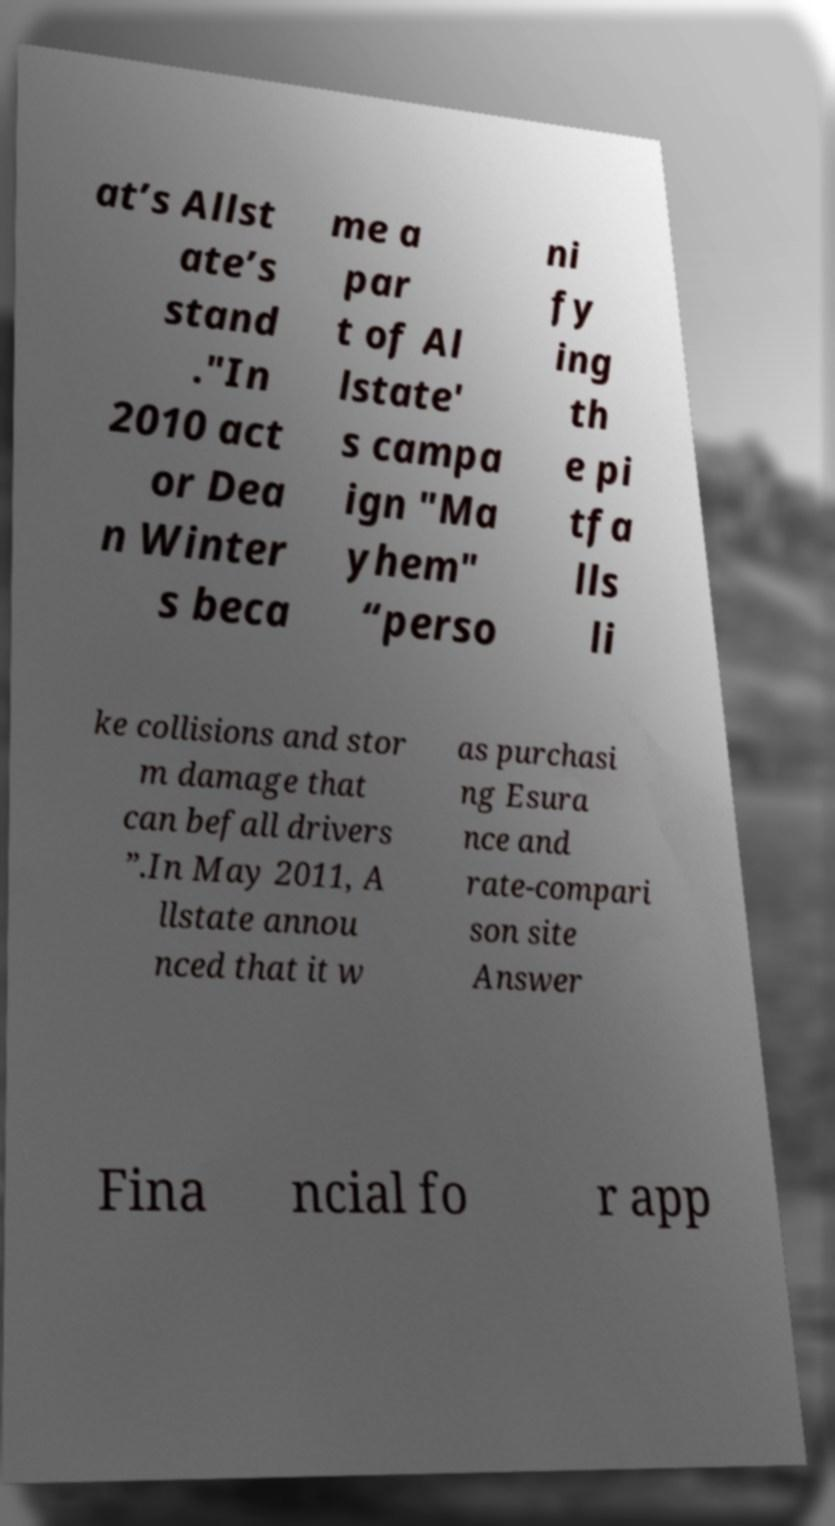Could you assist in decoding the text presented in this image and type it out clearly? at’s Allst ate’s stand ."In 2010 act or Dea n Winter s beca me a par t of Al lstate' s campa ign "Ma yhem" “perso ni fy ing th e pi tfa lls li ke collisions and stor m damage that can befall drivers ”.In May 2011, A llstate annou nced that it w as purchasi ng Esura nce and rate-compari son site Answer Fina ncial fo r app 